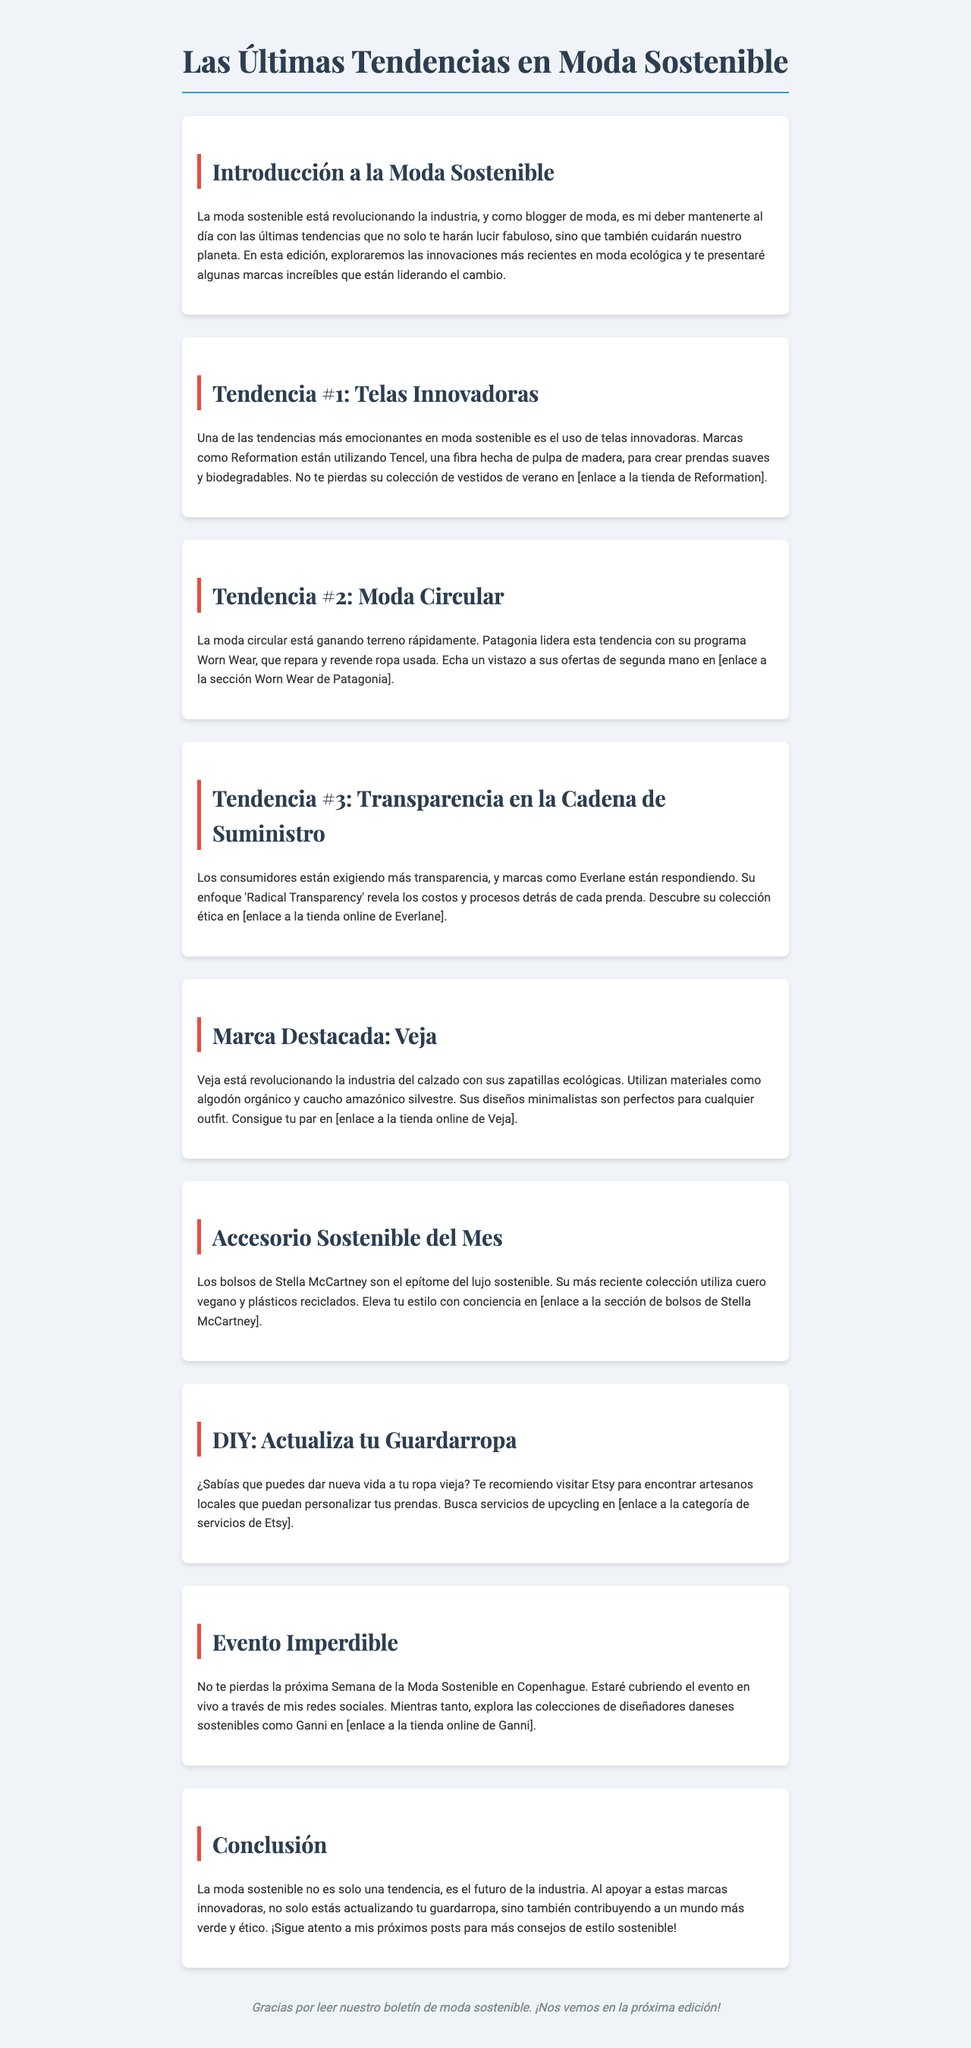¿Qué es la moda sostenible? La moda sostenible se refiere a un enfoque de la industria de la moda que busca ser responsable con el medio ambiente y socialmente ético.
Answer: Un enfoque responsable ¿Cuál es la primera tendencia mencionada? La primera tendencia discutida en el boletín es el uso de telas innovadoras.
Answer: Telas Innovadoras ¿Qué fibra utiliza Reformation? Reformation utiliza Tencel, una fibra hecha de pulpa de madera.
Answer: Tencel ¿Qué programa tiene Patagonia para ropa usada? Patagonia tiene el programa Worn Wear, que repara y revende ropa usada.
Answer: Worn Wear ¿Qué enfoque adopta Everlane? Everlane adopta el enfoque 'Radical Transparency' en su cadena de suministro.
Answer: Radical Transparency ¿Qué marca de calzado se destaca en el boletín? La marca destacada para zapatos ecológicos es Veja.
Answer: Veja ¿Qué tipo de cuero utilizan los bolsos de Stella McCartney? Los bolsos de Stella McCartney utilizan cuero vegano.
Answer: Cuero vegano ¿Cuál es el evento próximo mencionado? Se menciona la próxima Semana de la Moda Sostenible en Copenhague.
Answer: Semana de la Moda Sostenible ¿Qué recomendación se hace para actualizar el guardarropa? Se recomienda visitar Etsy para encontrar artesanos que puedan personalizar ropa vieja.
Answer: Visitar Etsy 